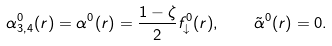<formula> <loc_0><loc_0><loc_500><loc_500>\alpha _ { 3 , 4 } ^ { 0 } ( r ) = \alpha ^ { 0 } ( r ) = \frac { 1 - \zeta } { 2 } f _ { \downarrow } ^ { 0 } ( r ) , \quad \tilde { \alpha } ^ { 0 } ( r ) = 0 .</formula> 